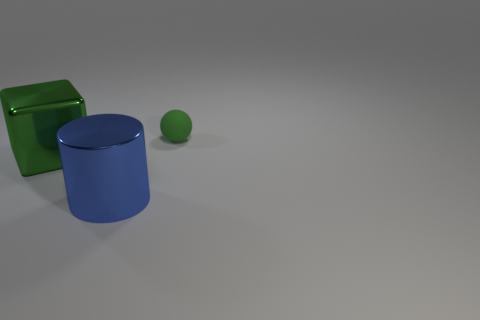Is there anything else that is the same shape as the small thing?
Offer a very short reply. No. There is a green object that is in front of the green rubber sphere; is its shape the same as the small matte object?
Give a very brief answer. No. There is a green object that is to the left of the matte object; is its size the same as the green rubber ball?
Ensure brevity in your answer.  No. Is there anything else that is the same color as the cube?
Your answer should be very brief. Yes. What is the shape of the large blue metal thing?
Offer a very short reply. Cylinder. What number of things are both left of the matte object and behind the large blue shiny object?
Offer a very short reply. 1. Is the color of the tiny matte object the same as the cube?
Offer a terse response. Yes. Are there any other things that are the same material as the big cylinder?
Offer a very short reply. Yes. Are there the same number of spheres to the left of the cube and metallic blocks that are to the right of the small sphere?
Your response must be concise. Yes. Does the large blue cylinder have the same material as the big green object?
Provide a succinct answer. Yes. 